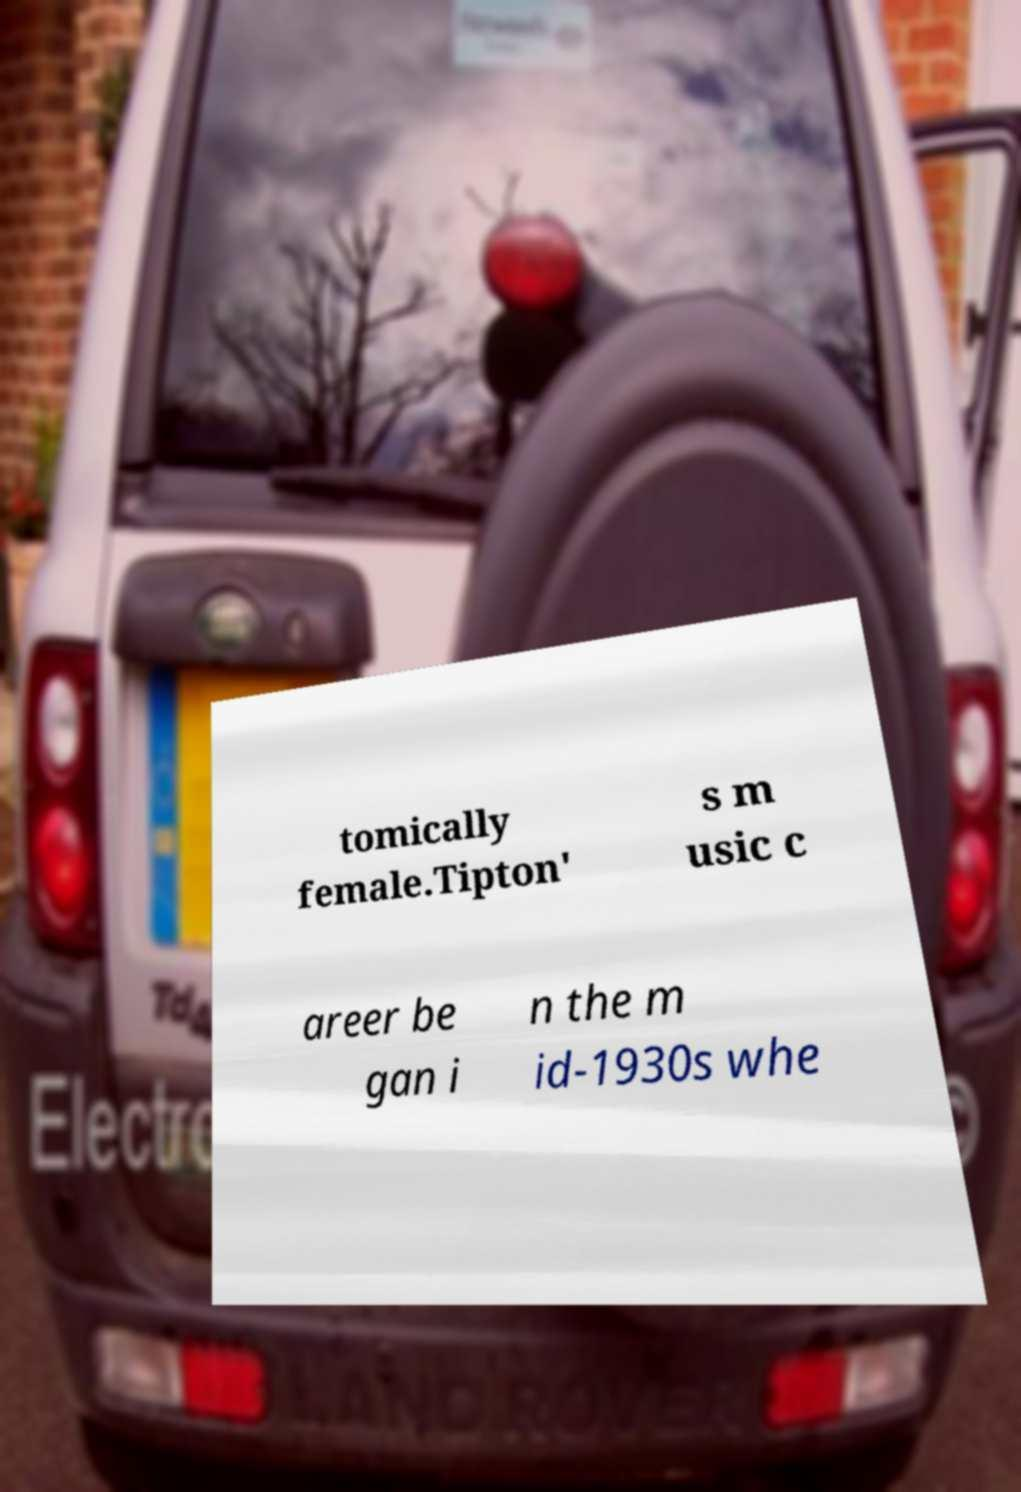Can you accurately transcribe the text from the provided image for me? tomically female.Tipton' s m usic c areer be gan i n the m id-1930s whe 